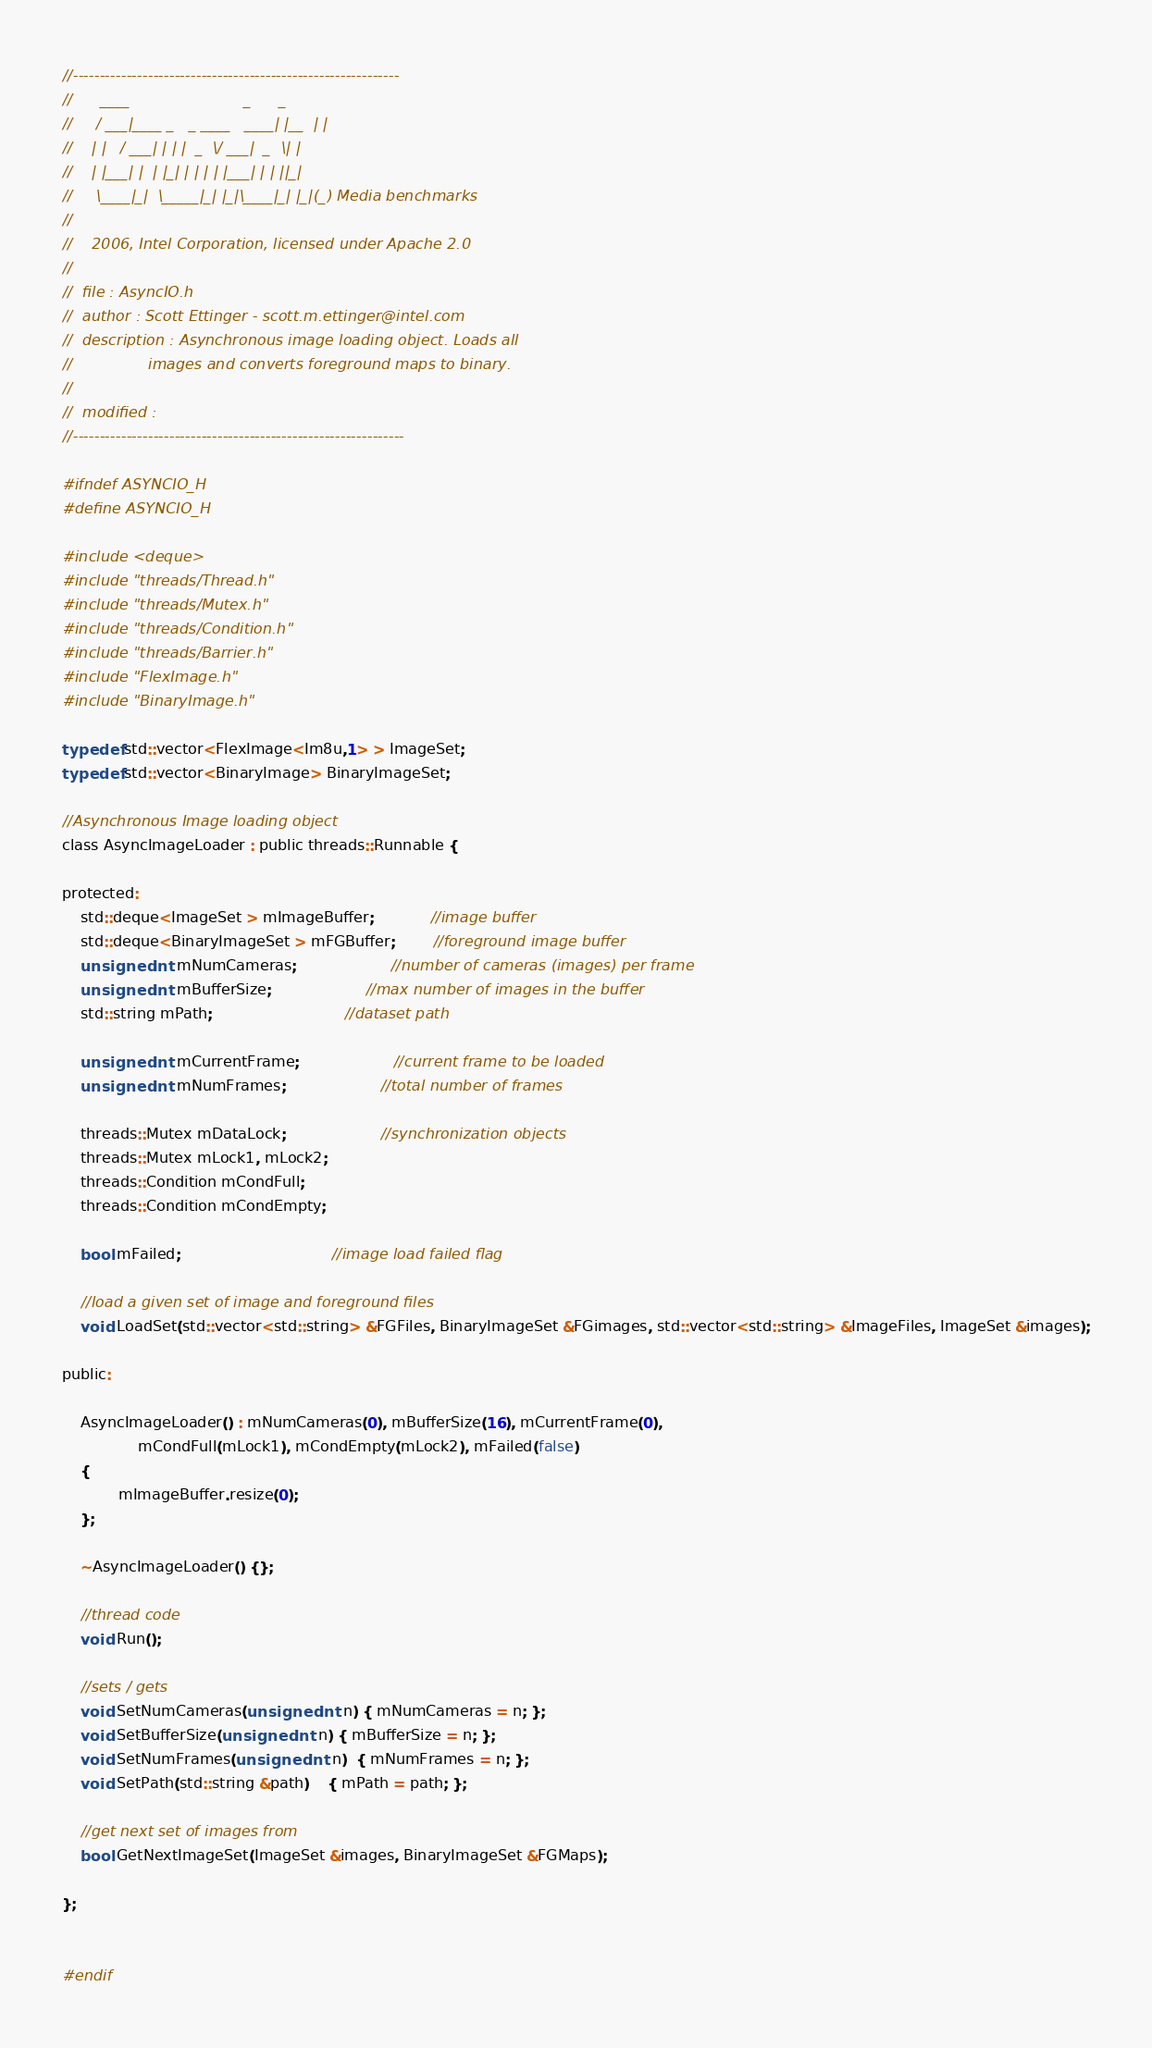Convert code to text. <code><loc_0><loc_0><loc_500><loc_500><_C_>//-------------------------------------------------------------
//      ____                        _      _
//     / ___|____ _   _ ____   ____| |__  | |
//    | |   / ___| | | |  _  \/ ___|  _  \| |
//    | |___| |  | |_| | | | | |___| | | ||_|
//     \____|_|  \_____|_| |_|\____|_| |_|(_) Media benchmarks
//                  
//	  2006, Intel Corporation, licensed under Apache 2.0 
//
//  file : AsyncIO.h
//  author : Scott Ettinger - scott.m.ettinger@intel.com
//  description : Asynchronous image loading object. Loads all 
//				  images and converts foreground maps to binary.
//				  
//  modified : 
//--------------------------------------------------------------

#ifndef ASYNCIO_H
#define ASYNCIO_H

#include <deque>
#include "threads/Thread.h"
#include "threads/Mutex.h"
#include "threads/Condition.h"
#include "threads/Barrier.h"
#include "FlexImage.h"
#include "BinaryImage.h"

typedef std::vector<FlexImage<Im8u,1> > ImageSet;
typedef std::vector<BinaryImage> BinaryImageSet;

//Asynchronous Image loading object
class AsyncImageLoader : public threads::Runnable {

protected:
	std::deque<ImageSet > mImageBuffer;			//image buffer
	std::deque<BinaryImageSet > mFGBuffer;		//foreground image buffer
	unsigned int mNumCameras;					//number of cameras (images) per frame
	unsigned int mBufferSize;					//max number of images in the buffer
	std::string mPath;							//dataset path

	unsigned int mCurrentFrame;					//current frame to be loaded
	unsigned int mNumFrames;					//total number of frames

	threads::Mutex mDataLock;					//synchronization objects
	threads::Mutex mLock1, mLock2;			
	threads::Condition mCondFull;
	threads::Condition mCondEmpty;

	bool mFailed;								//image load failed flag

	//load a given set of image and foreground files
	void LoadSet(std::vector<std::string> &FGFiles, BinaryImageSet &FGimages, std::vector<std::string> &ImageFiles, ImageSet &images);

public:

	AsyncImageLoader() : mNumCameras(0), mBufferSize(16), mCurrentFrame(0),  
                mCondFull(mLock1), mCondEmpty(mLock2), mFailed(false)
	{	
            mImageBuffer.resize(0); 
	};

	~AsyncImageLoader() {};

	//thread code
	void Run();

	//sets / gets
	void SetNumCameras(unsigned int n) { mNumCameras = n; };
	void SetBufferSize(unsigned int n) { mBufferSize = n; };
	void SetNumFrames(unsigned int n)  { mNumFrames = n; };
	void SetPath(std::string &path)    { mPath = path; };
	
	//get next set of images from 
	bool GetNextImageSet(ImageSet &images, BinaryImageSet &FGMaps);

};


#endif

</code> 